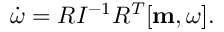Convert formula to latex. <formula><loc_0><loc_0><loc_500><loc_500>\begin{array} { r } { \dot { \boldsymbol \omega } = R I ^ { - 1 } R ^ { T } [ { m } , { \boldsymbol \omega } ] . } \end{array}</formula> 